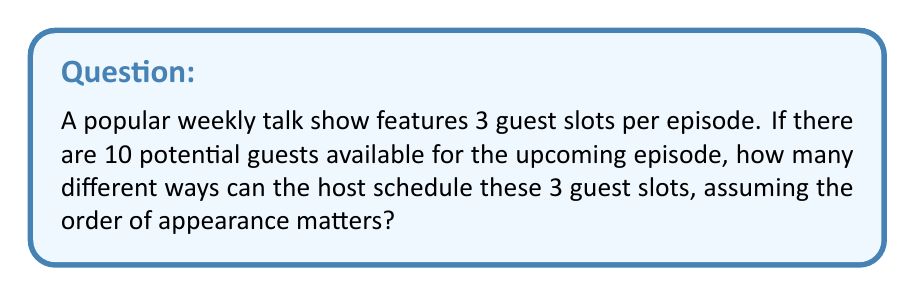Teach me how to tackle this problem. Let's approach this step-by-step:

1) This is a permutation problem because the order of appearance matters.

2) We are selecting 3 guests out of 10, and the order is important.

3) The formula for permutations is:

   $$P(n,r) = \frac{n!}{(n-r)!}$$

   Where $n$ is the total number of items to choose from, and $r$ is the number of items being chosen.

4) In this case, $n = 10$ (total potential guests) and $r = 3$ (guest slots to fill).

5) Plugging these values into our formula:

   $$P(10,3) = \frac{10!}{(10-3)!} = \frac{10!}{7!}$$

6) Expanding this:

   $$\frac{10 \times 9 \times 8 \times 7!}{7!}$$

7) The 7! cancels out in the numerator and denominator:

   $$10 \times 9 \times 8 = 720$$

Therefore, there are 720 different ways to schedule 3 guests out of 10 potential guests for the talk show.
Answer: 720 